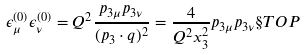<formula> <loc_0><loc_0><loc_500><loc_500>\epsilon _ { \mu } ^ { ( 0 ) } \epsilon _ { \nu } ^ { ( 0 ) } = Q ^ { 2 } \frac { p _ { 3 \mu } p _ { 3 \nu } } { ( p _ { 3 } \cdot q ) ^ { 2 } } = \frac { 4 } { Q ^ { 2 } x _ { 3 } ^ { 2 } } p _ { 3 \mu } p _ { 3 \nu } \S T O P</formula> 